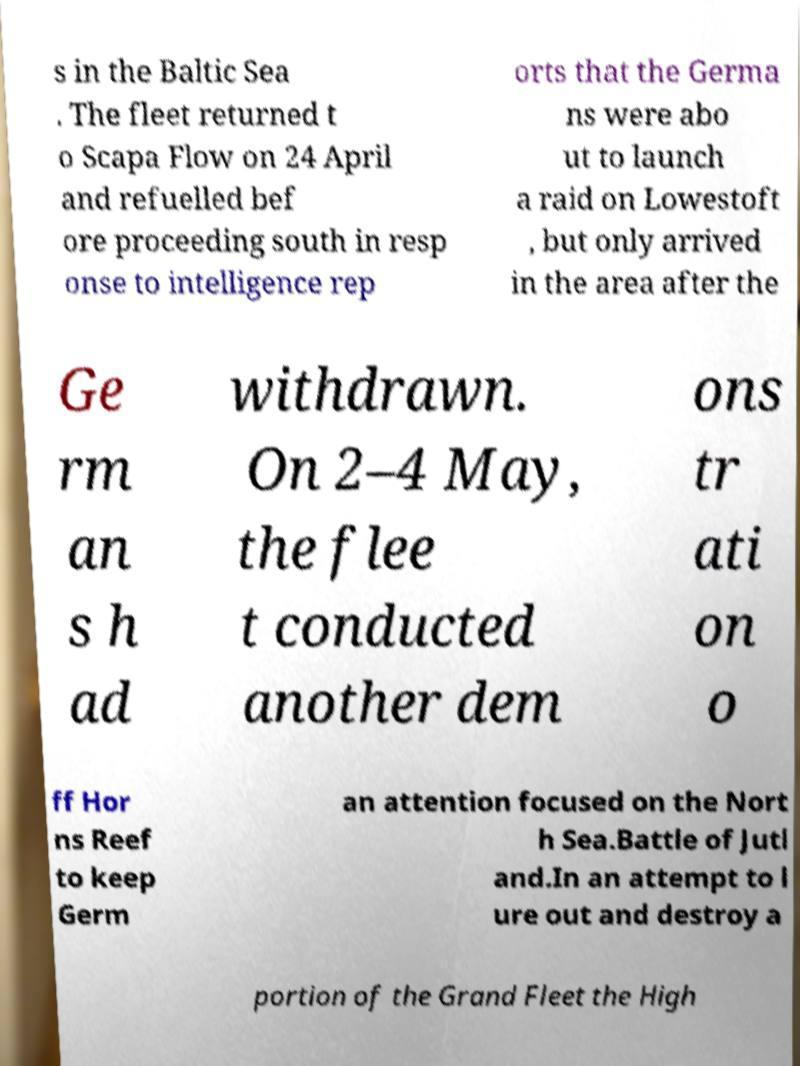Can you accurately transcribe the text from the provided image for me? s in the Baltic Sea . The fleet returned t o Scapa Flow on 24 April and refuelled bef ore proceeding south in resp onse to intelligence rep orts that the Germa ns were abo ut to launch a raid on Lowestoft , but only arrived in the area after the Ge rm an s h ad withdrawn. On 2–4 May, the flee t conducted another dem ons tr ati on o ff Hor ns Reef to keep Germ an attention focused on the Nort h Sea.Battle of Jutl and.In an attempt to l ure out and destroy a portion of the Grand Fleet the High 